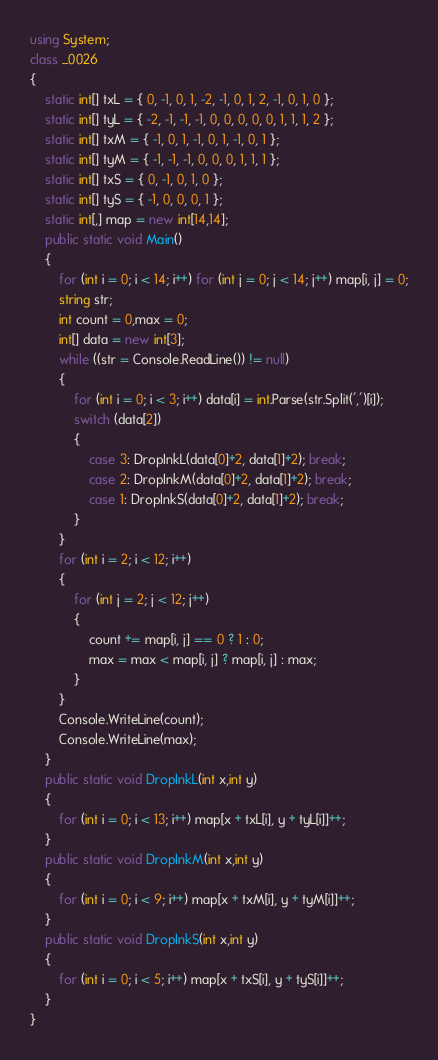<code> <loc_0><loc_0><loc_500><loc_500><_C#_>using System;
class _0026
{
    static int[] txL = { 0, -1, 0, 1, -2, -1, 0, 1, 2, -1, 0, 1, 0 };
    static int[] tyL = { -2, -1, -1, -1, 0, 0, 0, 0, 0, 1, 1, 1, 2 };
    static int[] txM = { -1, 0, 1, -1, 0, 1, -1, 0, 1 };
    static int[] tyM = { -1, -1, -1, 0, 0, 0, 1, 1, 1 };
    static int[] txS = { 0, -1, 0, 1, 0 };
    static int[] tyS = { -1, 0, 0, 0, 1 };
    static int[,] map = new int[14,14];
    public static void Main()
    {
        for (int i = 0; i < 14; i++) for (int j = 0; j < 14; j++) map[i, j] = 0;
        string str;
        int count = 0,max = 0;
        int[] data = new int[3];
        while ((str = Console.ReadLine()) != null)
        {
            for (int i = 0; i < 3; i++) data[i] = int.Parse(str.Split(',')[i]);
            switch (data[2])
            {
                case 3: DropInkL(data[0]+2, data[1]+2); break;
                case 2: DropInkM(data[0]+2, data[1]+2); break;
                case 1: DropInkS(data[0]+2, data[1]+2); break;
            }
        }
        for (int i = 2; i < 12; i++)
        {
            for (int j = 2; j < 12; j++)
            {
                count += map[i, j] == 0 ? 1 : 0;
                max = max < map[i, j] ? map[i, j] : max;
            }
        }
        Console.WriteLine(count);
        Console.WriteLine(max);
    }
    public static void DropInkL(int x,int y)
    {
        for (int i = 0; i < 13; i++) map[x + txL[i], y + tyL[i]]++;
    }
    public static void DropInkM(int x,int y)
    {
        for (int i = 0; i < 9; i++) map[x + txM[i], y + tyM[i]]++;
    }
    public static void DropInkS(int x,int y)
    {
        for (int i = 0; i < 5; i++) map[x + txS[i], y + tyS[i]]++;
    }
}</code> 